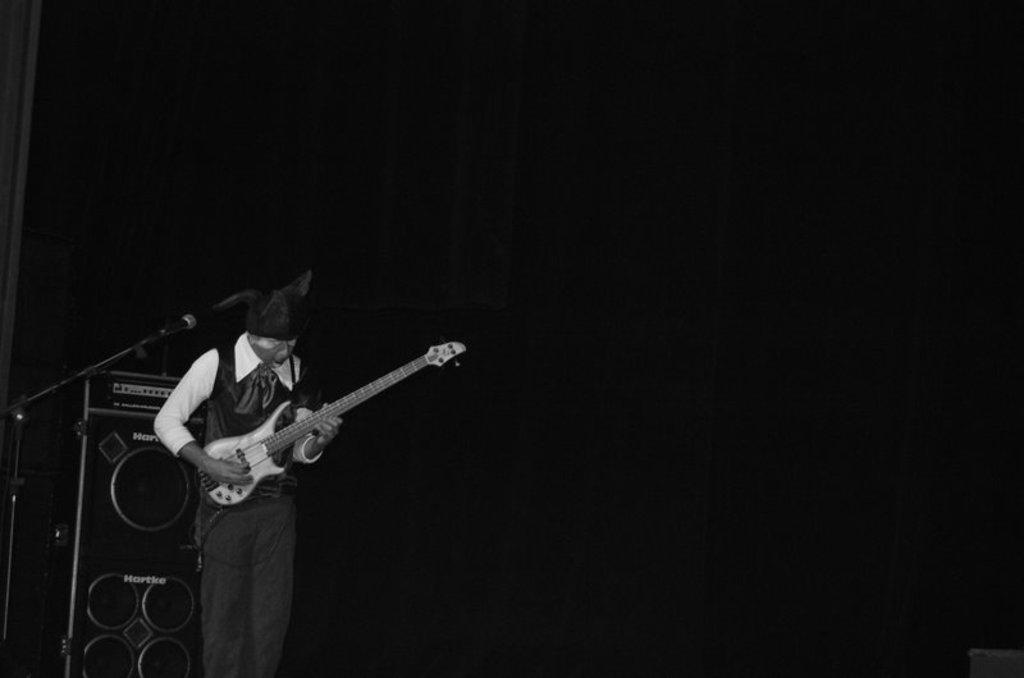Who is the main subject in the image? There is a person in the image. What is the person doing in the image? The person is playing the guitar and standing in front of a mic. What can be seen in the background of the image? There is a sound system in the background of the image. What type of furniture is being discussed by the beast in the image? There is no beast or discussion about furniture present in the image. 